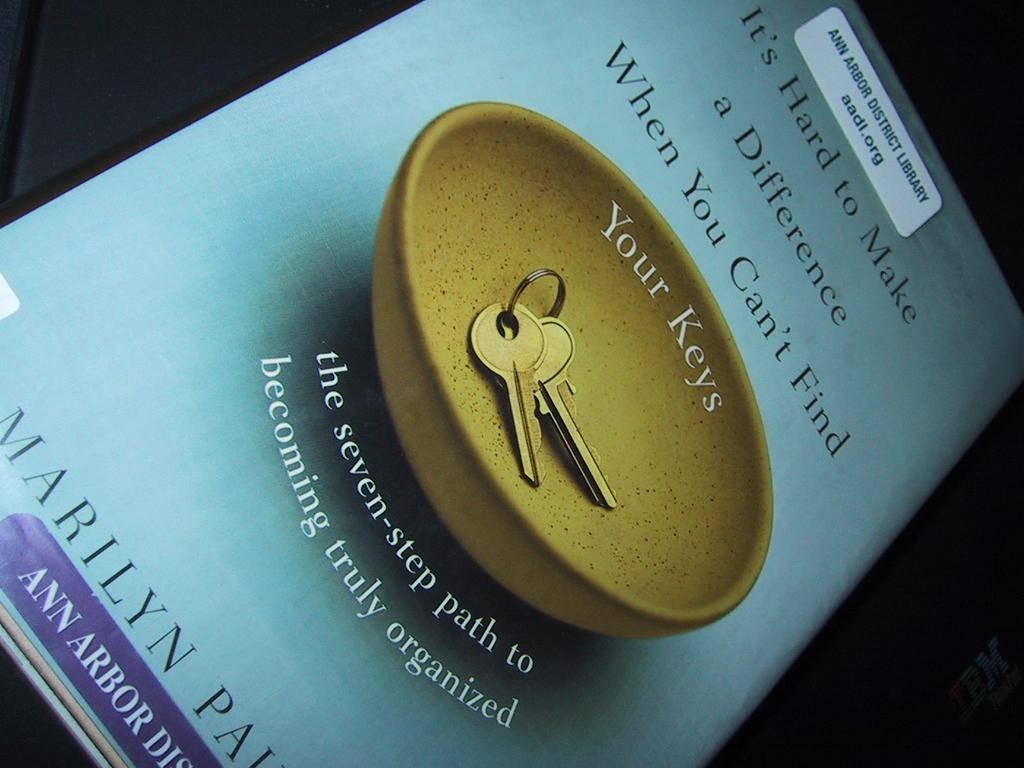What is the book called?
Your answer should be compact. It's hard to make a difference when you can't find your keys. 